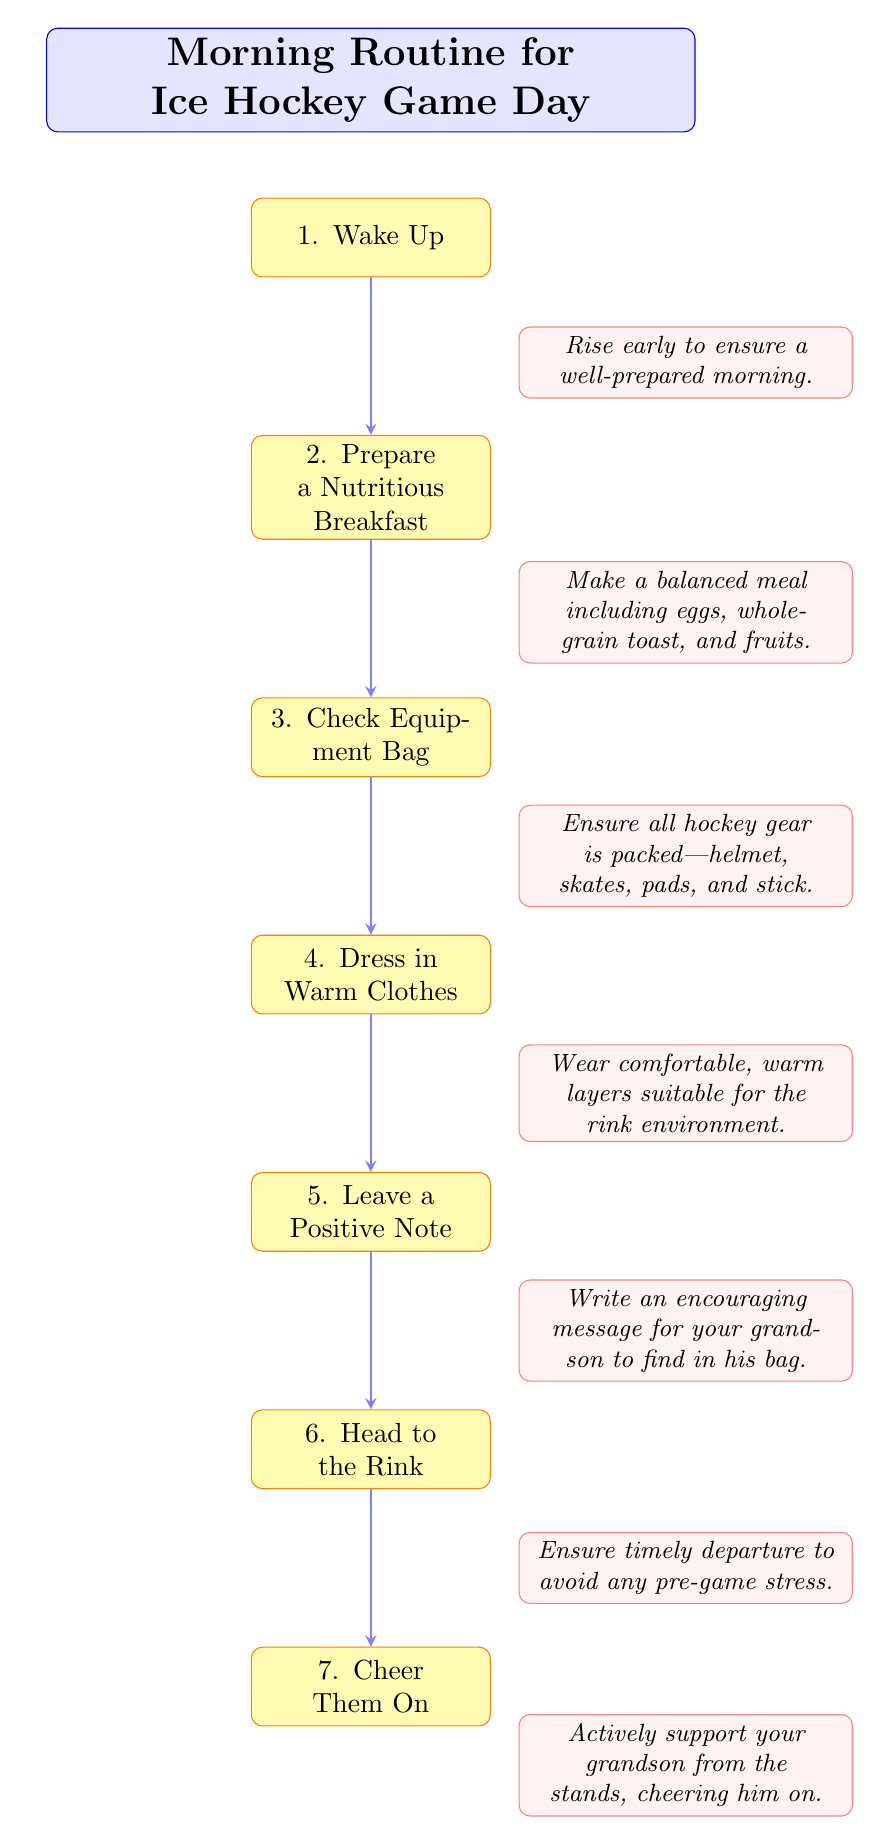What is the starting point of the morning routine? The first node in the flow chart is "Wake Up," indicating that the morning routine begins here.
Answer: Wake Up How many nodes are there in the diagram? The flow chart consists of 7 nodes, each representing a step in the morning routine before the game.
Answer: 7 What does the second step of the routine involve? The second node in the flow chart is "Prepare a Nutritious Breakfast," which outlines the importance of having a balanced meal to start the day.
Answer: Prepare a Nutritious Breakfast What is the last activity before heading to the rink? The flow chart indicates that the last activity before heading to the rink is "Leave a Positive Note," which emphasizes encouraging messages for your grandson.
Answer: Leave a Positive Note What are the two activities that follow "Check Equipment Bag"? The diagram shows that the activities following "Check Equipment Bag" are "Dress in Warm Clothes" and then "Leave a Positive Note," highlighting the preparations after checking hockey gear.
Answer: Dress in Warm Clothes, Leave a Positive Note Which node signifies an action performed at the rink? The last node in the flow chart is "Cheer Them On," signifying that this action pertains to supporting your grandson during the game at the rink.
Answer: Cheer Them On What is the main purpose of the flow chart? The overall purpose of the flow chart is to guide someone through a structured "Morning Routine for Ice Hockey Game Day," ensuring that all essential steps are followed for preparation.
Answer: Morning Routine for Ice Hockey Game Day What is the relationship between "Prepare a Nutritious Breakfast" and "Check Equipment Bag"? The flow chart connects "Prepare a Nutritious Breakfast" directly to "Check Equipment Bag," indicating that these steps are sequential in the morning routine before heading to the rink.
Answer: Sequential relationship 